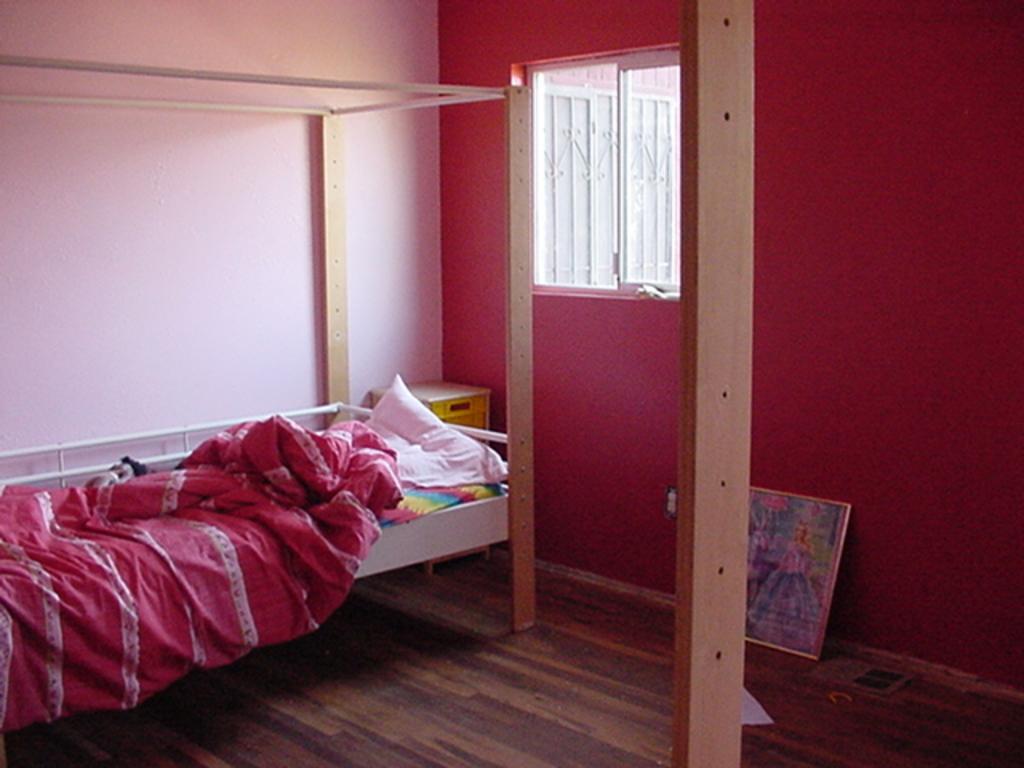Can you describe this image briefly? In this picture we can see a photo frame, cot on the floor, here we can see clothes, pillow, wooden pole and some objects and in the background we can see a wall, window. 